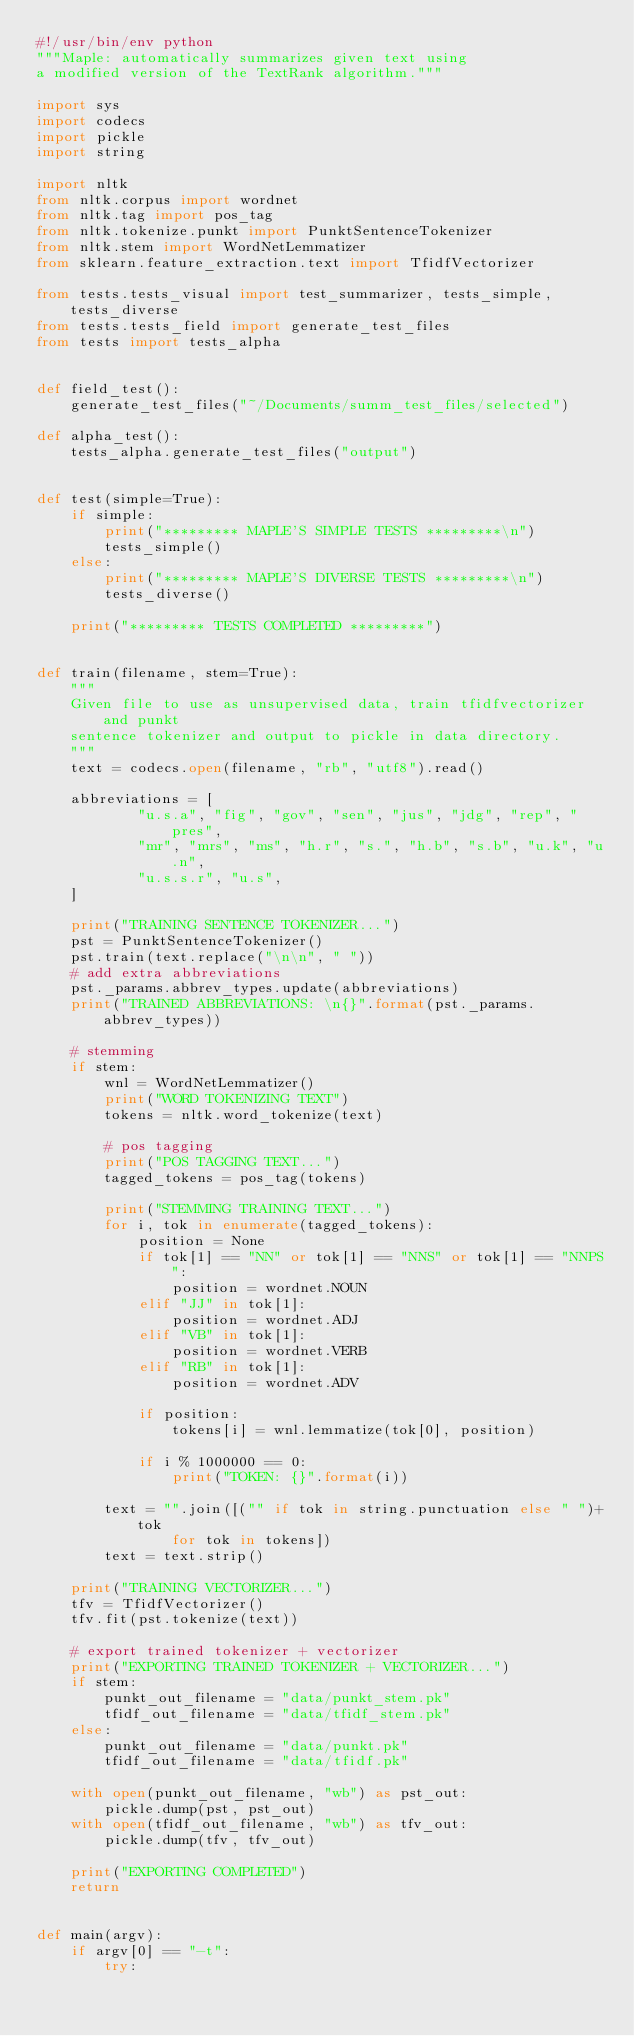Convert code to text. <code><loc_0><loc_0><loc_500><loc_500><_Python_>#!/usr/bin/env python
"""Maple: automatically summarizes given text using
a modified version of the TextRank algorithm."""

import sys
import codecs
import pickle
import string

import nltk
from nltk.corpus import wordnet
from nltk.tag import pos_tag
from nltk.tokenize.punkt import PunktSentenceTokenizer
from nltk.stem import WordNetLemmatizer
from sklearn.feature_extraction.text import TfidfVectorizer

from tests.tests_visual import test_summarizer, tests_simple, tests_diverse 
from tests.tests_field import generate_test_files
from tests import tests_alpha


def field_test():
    generate_test_files("~/Documents/summ_test_files/selected")

def alpha_test():
    tests_alpha.generate_test_files("output")


def test(simple=True):
    if simple:
        print("********* MAPLE'S SIMPLE TESTS *********\n")
        tests_simple()
    else:
        print("********* MAPLE'S DIVERSE TESTS *********\n")
        tests_diverse()

    print("********* TESTS COMPLETED *********")


def train(filename, stem=True):
    """
    Given file to use as unsupervised data, train tfidfvectorizer and punkt
    sentence tokenizer and output to pickle in data directory.
    """
    text = codecs.open(filename, "rb", "utf8").read()

    abbreviations = [
            "u.s.a", "fig", "gov", "sen", "jus", "jdg", "rep", "pres",
            "mr", "mrs", "ms", "h.r", "s.", "h.b", "s.b", "u.k", "u.n",
            "u.s.s.r", "u.s",
    ]

    print("TRAINING SENTENCE TOKENIZER...")
    pst = PunktSentenceTokenizer()
    pst.train(text.replace("\n\n", " "))
    # add extra abbreviations
    pst._params.abbrev_types.update(abbreviations)    
    print("TRAINED ABBREVIATIONS: \n{}".format(pst._params.abbrev_types))
    
    # stemming
    if stem:
        wnl = WordNetLemmatizer()
        print("WORD TOKENIZING TEXT")
        tokens = nltk.word_tokenize(text)
        
        # pos tagging
        print("POS TAGGING TEXT...")
        tagged_tokens = pos_tag(tokens)

        print("STEMMING TRAINING TEXT...")
        for i, tok in enumerate(tagged_tokens):
            position = None
            if tok[1] == "NN" or tok[1] == "NNS" or tok[1] == "NNPS":
                position = wordnet.NOUN
            elif "JJ" in tok[1]:
                position = wordnet.ADJ
            elif "VB" in tok[1]:
                position = wordnet.VERB
            elif "RB" in tok[1]:
                position = wordnet.ADV

            if position:
                tokens[i] = wnl.lemmatize(tok[0], position)

            if i % 1000000 == 0:
                print("TOKEN: {}".format(i))

        text = "".join([("" if tok in string.punctuation else " ")+tok 
                for tok in tokens])
        text = text.strip() 
    
    print("TRAINING VECTORIZER...")
    tfv = TfidfVectorizer()
    tfv.fit(pst.tokenize(text))

    # export trained tokenizer + vectorizer
    print("EXPORTING TRAINED TOKENIZER + VECTORIZER...")
    if stem:
        punkt_out_filename = "data/punkt_stem.pk"
        tfidf_out_filename = "data/tfidf_stem.pk"
    else:
        punkt_out_filename = "data/punkt.pk"
        tfidf_out_filename = "data/tfidf.pk"

    with open(punkt_out_filename, "wb") as pst_out:
        pickle.dump(pst, pst_out)
    with open(tfidf_out_filename, "wb") as tfv_out:
        pickle.dump(tfv, tfv_out)

    print("EXPORTING COMPLETED")
    return


def main(argv):       
    if argv[0] == "-t":
        try:</code> 